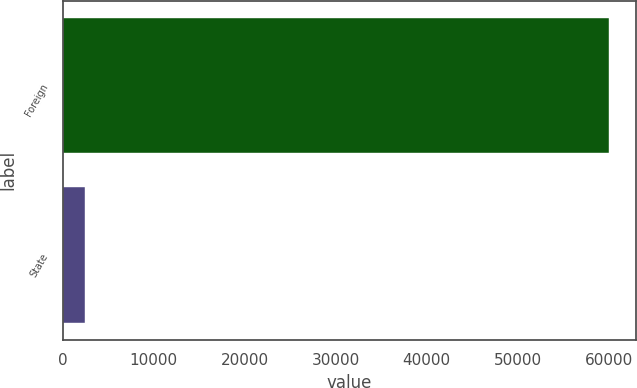Convert chart. <chart><loc_0><loc_0><loc_500><loc_500><bar_chart><fcel>Foreign<fcel>State<nl><fcel>60033<fcel>2435<nl></chart> 